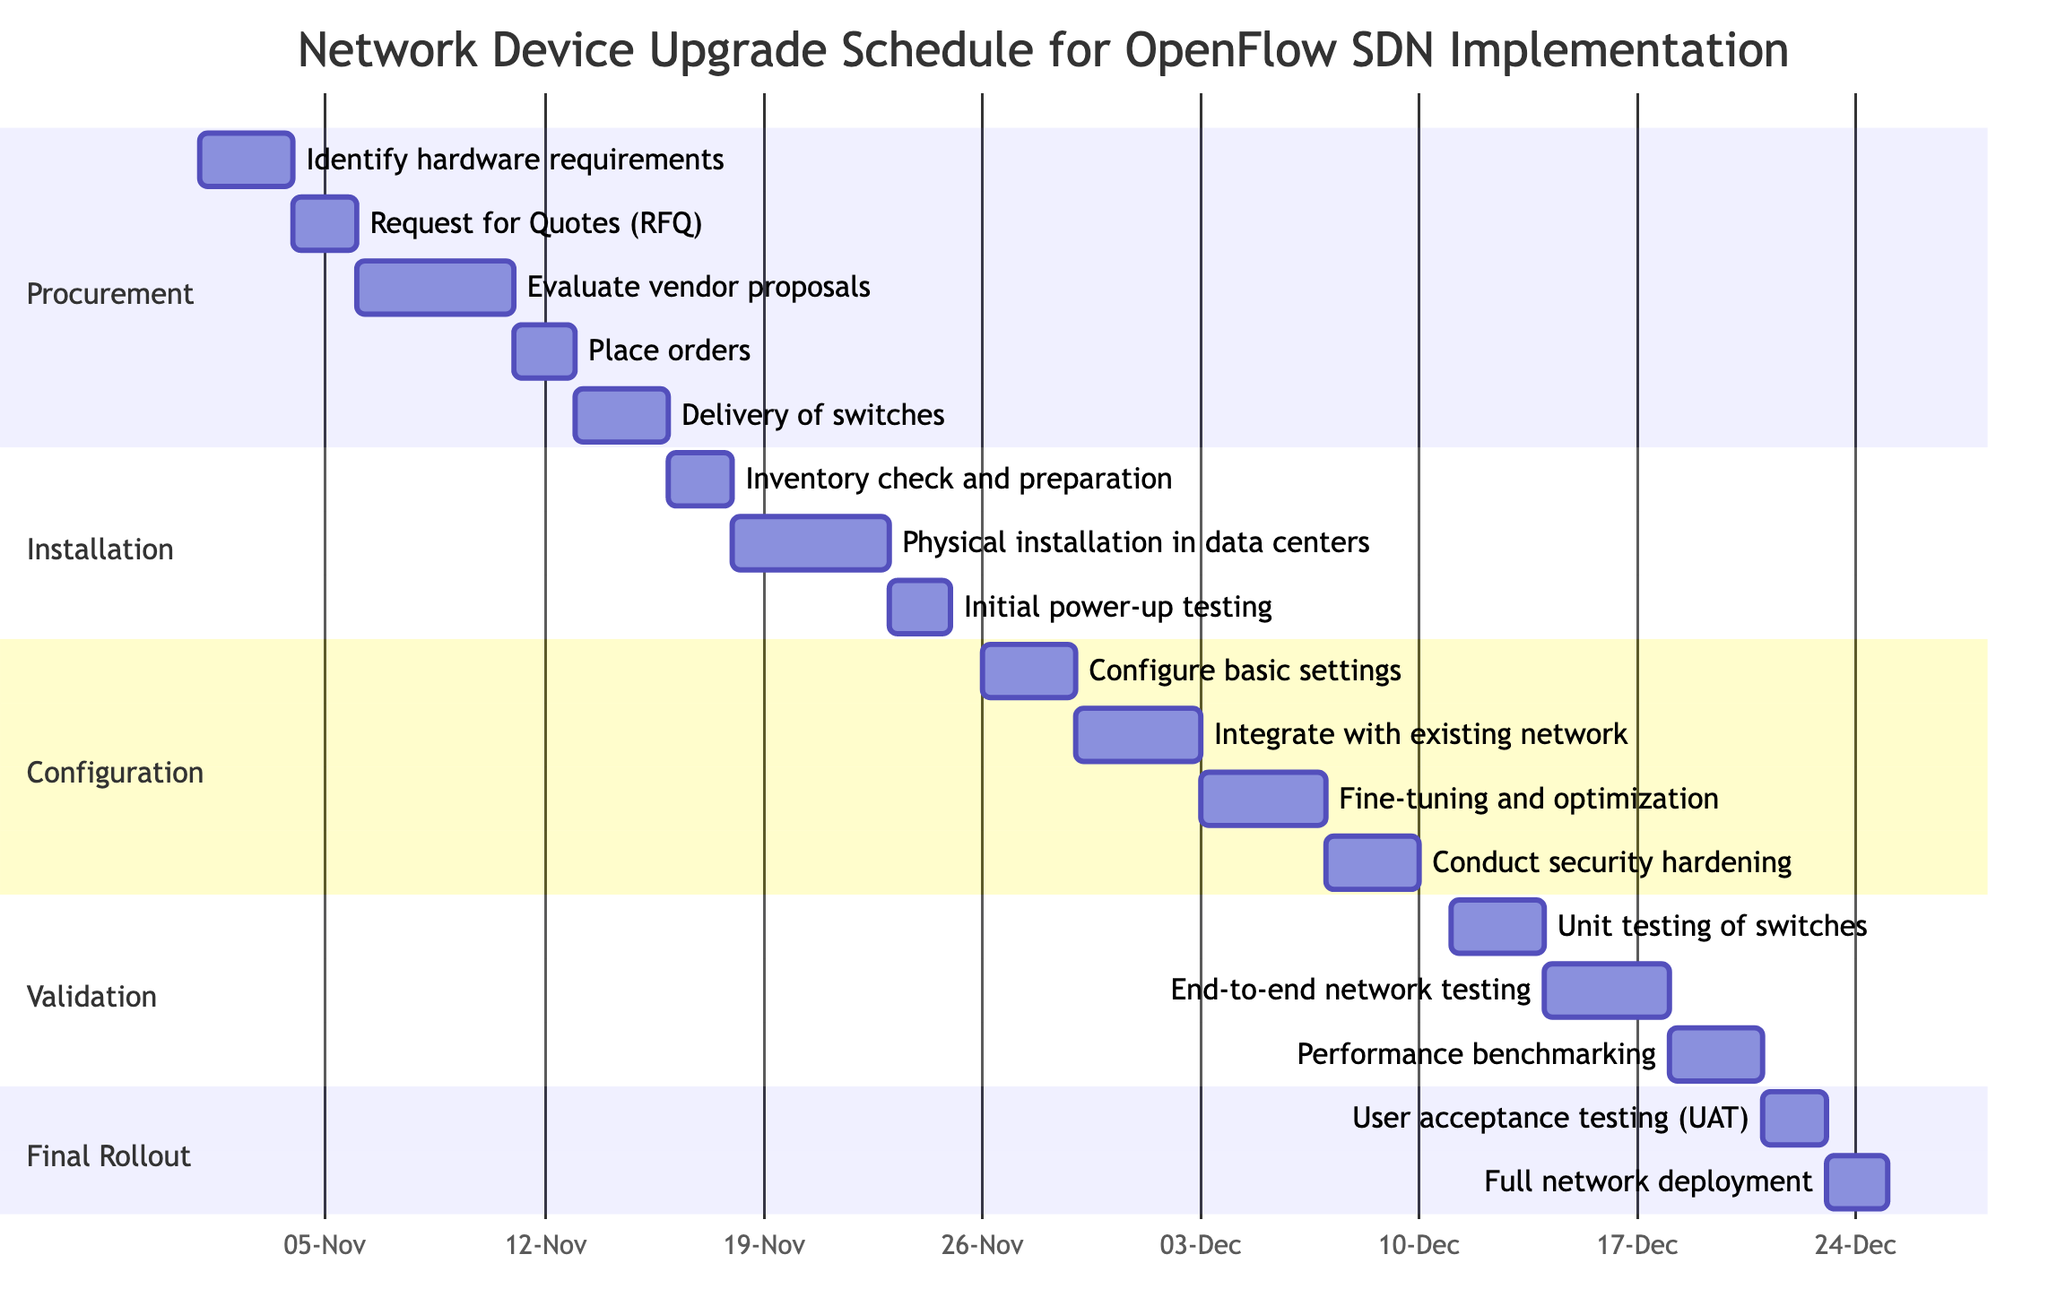What is the duration of the Configuration Phase? The Configuration Phase includes four subtasks with durations of 3, 4, 4, and 3 days respectively. Summing these gives us a total of 14 days.
Answer: 14 days When does the Installation of New Switches start? The Installation of New Switches phase starts immediately after the Procurement phase, beginning on November 16, 2023.
Answer: November 16, 2023 How many days are allocated for Delivery of switches? The Delivery of switches task is assigned a duration of 3 days, as indicated in the Procurement section of the diagram.
Answer: 3 days What task follows the Initial power-up testing? Following the Initial power-up testing task, the next task in the Installation section is the Configuration Phase, which starts on November 26, 2023.
Answer: Configuration Phase What is the total duration for Validation and Testing? The Validation and Testing phase consists of three tasks: Unit testing of switches (3 days), End-to-end network testing (4 days), and Performance benchmarking (3 days). Adding these gives a total duration of 10 days.
Answer: 10 days Which task has the longest duration in the Configuration Phase? In the Configuration Phase, the task "Integrate with existing network" lasts for 4 days, which is the longest duration among the four subtasks listed.
Answer: Integrate with existing network What is the end date of the Final Rollout? The Final Rollout phase concludes on December 24, 2023, which is detailed in the diagram as the last task scheduled.
Answer: December 24, 2023 Which task is scheduled directly before User acceptance testing (UAT)? Directly before User acceptance testing (UAT), the Full network deployment task is scheduled, appearing in the Final Rollout section after UAT.
Answer: Full network deployment How many tasks are there in the entire upgrade schedule? Counting all the main tasks and their respective subtasks in the Gantt Chart, there are a total of 5 main tasks and 15 subtasks, leading to 20 tasks in total.
Answer: 20 tasks 